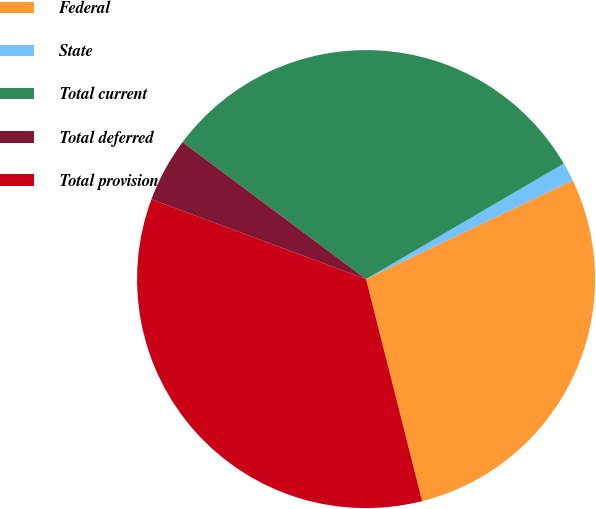<chart> <loc_0><loc_0><loc_500><loc_500><pie_chart><fcel>Federal<fcel>State<fcel>Total current<fcel>Total deferred<fcel>Total provision<nl><fcel>28.16%<fcel>1.32%<fcel>31.38%<fcel>4.54%<fcel>34.6%<nl></chart> 